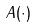Convert formula to latex. <formula><loc_0><loc_0><loc_500><loc_500>A ( \cdot )</formula> 